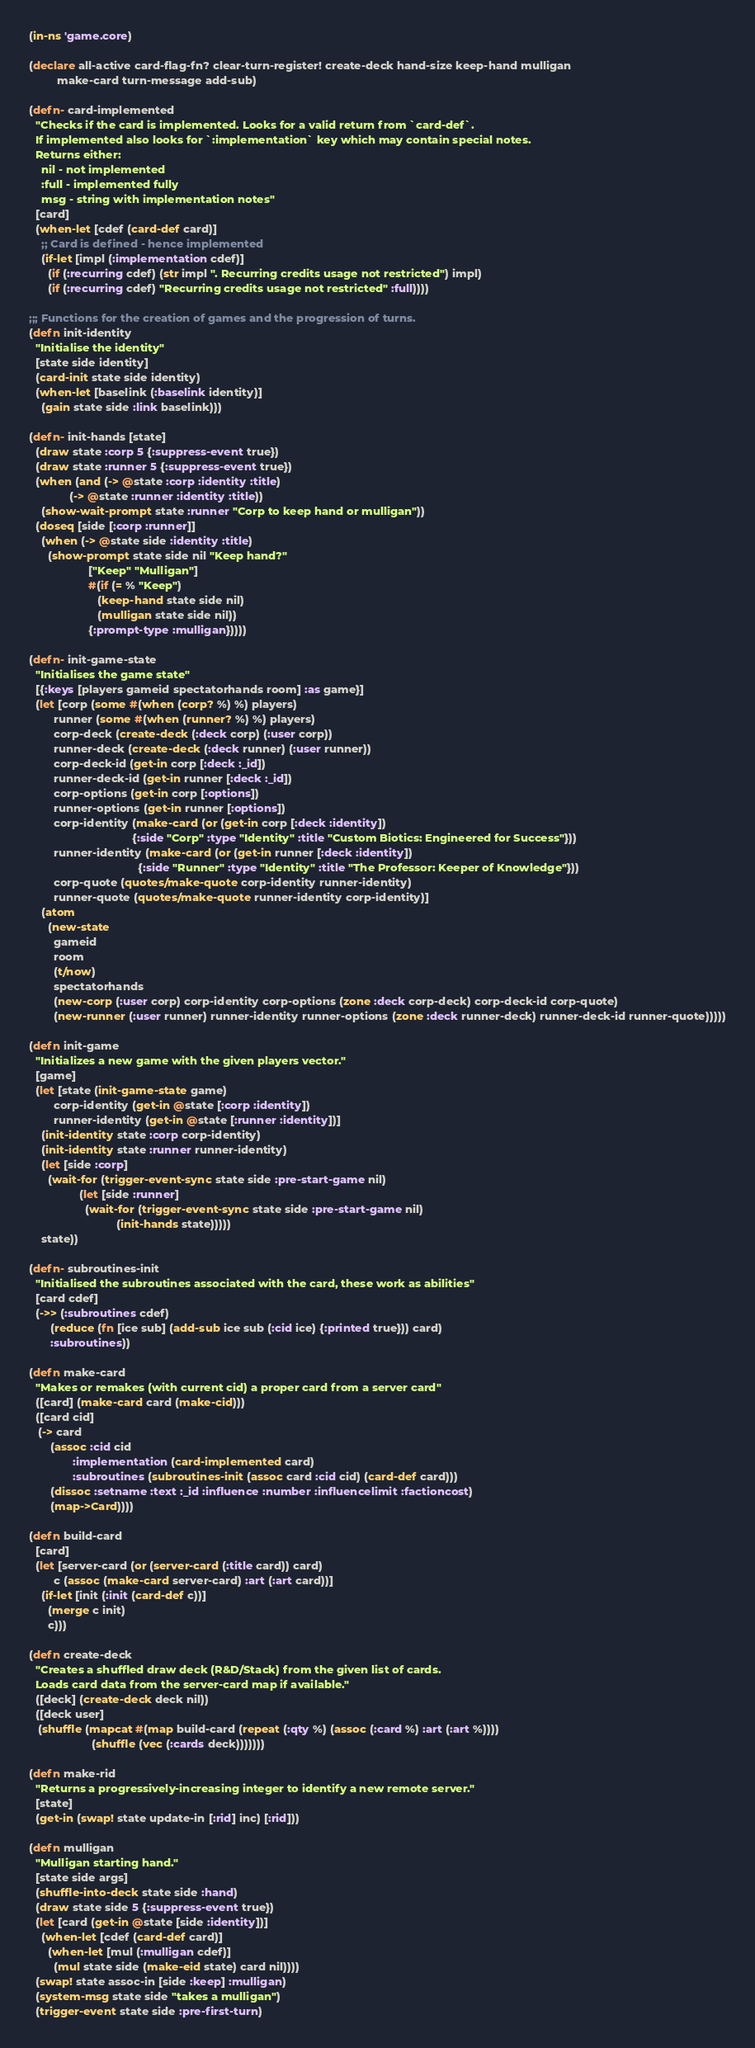Convert code to text. <code><loc_0><loc_0><loc_500><loc_500><_Clojure_>(in-ns 'game.core)

(declare all-active card-flag-fn? clear-turn-register! create-deck hand-size keep-hand mulligan
         make-card turn-message add-sub)

(defn- card-implemented
  "Checks if the card is implemented. Looks for a valid return from `card-def`.
  If implemented also looks for `:implementation` key which may contain special notes.
  Returns either:
    nil - not implemented
    :full - implemented fully
    msg - string with implementation notes"
  [card]
  (when-let [cdef (card-def card)]
    ;; Card is defined - hence implemented
    (if-let [impl (:implementation cdef)]
      (if (:recurring cdef) (str impl ". Recurring credits usage not restricted") impl)
      (if (:recurring cdef) "Recurring credits usage not restricted" :full))))

;;; Functions for the creation of games and the progression of turns.
(defn init-identity
  "Initialise the identity"
  [state side identity]
  (card-init state side identity)
  (when-let [baselink (:baselink identity)]
    (gain state side :link baselink)))

(defn- init-hands [state]
  (draw state :corp 5 {:suppress-event true})
  (draw state :runner 5 {:suppress-event true})
  (when (and (-> @state :corp :identity :title)
             (-> @state :runner :identity :title))
    (show-wait-prompt state :runner "Corp to keep hand or mulligan"))
  (doseq [side [:corp :runner]]
    (when (-> @state side :identity :title)
      (show-prompt state side nil "Keep hand?"
                   ["Keep" "Mulligan"]
                   #(if (= % "Keep")
                      (keep-hand state side nil)
                      (mulligan state side nil))
                   {:prompt-type :mulligan}))))

(defn- init-game-state
  "Initialises the game state"
  [{:keys [players gameid spectatorhands room] :as game}]
  (let [corp (some #(when (corp? %) %) players)
        runner (some #(when (runner? %) %) players)
        corp-deck (create-deck (:deck corp) (:user corp))
        runner-deck (create-deck (:deck runner) (:user runner))
        corp-deck-id (get-in corp [:deck :_id])
        runner-deck-id (get-in runner [:deck :_id])
        corp-options (get-in corp [:options])
        runner-options (get-in runner [:options])
        corp-identity (make-card (or (get-in corp [:deck :identity])
                                 {:side "Corp" :type "Identity" :title "Custom Biotics: Engineered for Success"}))
        runner-identity (make-card (or (get-in runner [:deck :identity])
                                   {:side "Runner" :type "Identity" :title "The Professor: Keeper of Knowledge"}))
        corp-quote (quotes/make-quote corp-identity runner-identity)
        runner-quote (quotes/make-quote runner-identity corp-identity)]
    (atom
      (new-state
        gameid
        room
        (t/now)
        spectatorhands
        (new-corp (:user corp) corp-identity corp-options (zone :deck corp-deck) corp-deck-id corp-quote)
        (new-runner (:user runner) runner-identity runner-options (zone :deck runner-deck) runner-deck-id runner-quote)))))

(defn init-game
  "Initializes a new game with the given players vector."
  [game]
  (let [state (init-game-state game)
        corp-identity (get-in @state [:corp :identity])
        runner-identity (get-in @state [:runner :identity])]
    (init-identity state :corp corp-identity)
    (init-identity state :runner runner-identity)
    (let [side :corp]
      (wait-for (trigger-event-sync state side :pre-start-game nil)
                (let [side :runner]
                  (wait-for (trigger-event-sync state side :pre-start-game nil)
                            (init-hands state)))))
    state))

(defn- subroutines-init
  "Initialised the subroutines associated with the card, these work as abilities"
  [card cdef]
  (->> (:subroutines cdef)
       (reduce (fn [ice sub] (add-sub ice sub (:cid ice) {:printed true})) card)
       :subroutines))

(defn make-card
  "Makes or remakes (with current cid) a proper card from a server card"
  ([card] (make-card card (make-cid)))
  ([card cid]
   (-> card
       (assoc :cid cid
              :implementation (card-implemented card)
              :subroutines (subroutines-init (assoc card :cid cid) (card-def card)))
       (dissoc :setname :text :_id :influence :number :influencelimit :factioncost)
       (map->Card))))

(defn build-card
  [card]
  (let [server-card (or (server-card (:title card)) card)
        c (assoc (make-card server-card) :art (:art card))]
    (if-let [init (:init (card-def c))]
      (merge c init)
      c)))

(defn create-deck
  "Creates a shuffled draw deck (R&D/Stack) from the given list of cards.
  Loads card data from the server-card map if available."
  ([deck] (create-deck deck nil))
  ([deck user]
   (shuffle (mapcat #(map build-card (repeat (:qty %) (assoc (:card %) :art (:art %))))
                    (shuffle (vec (:cards deck)))))))

(defn make-rid
  "Returns a progressively-increasing integer to identify a new remote server."
  [state]
  (get-in (swap! state update-in [:rid] inc) [:rid]))

(defn mulligan
  "Mulligan starting hand."
  [state side args]
  (shuffle-into-deck state side :hand)
  (draw state side 5 {:suppress-event true})
  (let [card (get-in @state [side :identity])]
    (when-let [cdef (card-def card)]
      (when-let [mul (:mulligan cdef)]
        (mul state side (make-eid state) card nil))))
  (swap! state assoc-in [side :keep] :mulligan)
  (system-msg state side "takes a mulligan")
  (trigger-event state side :pre-first-turn)</code> 